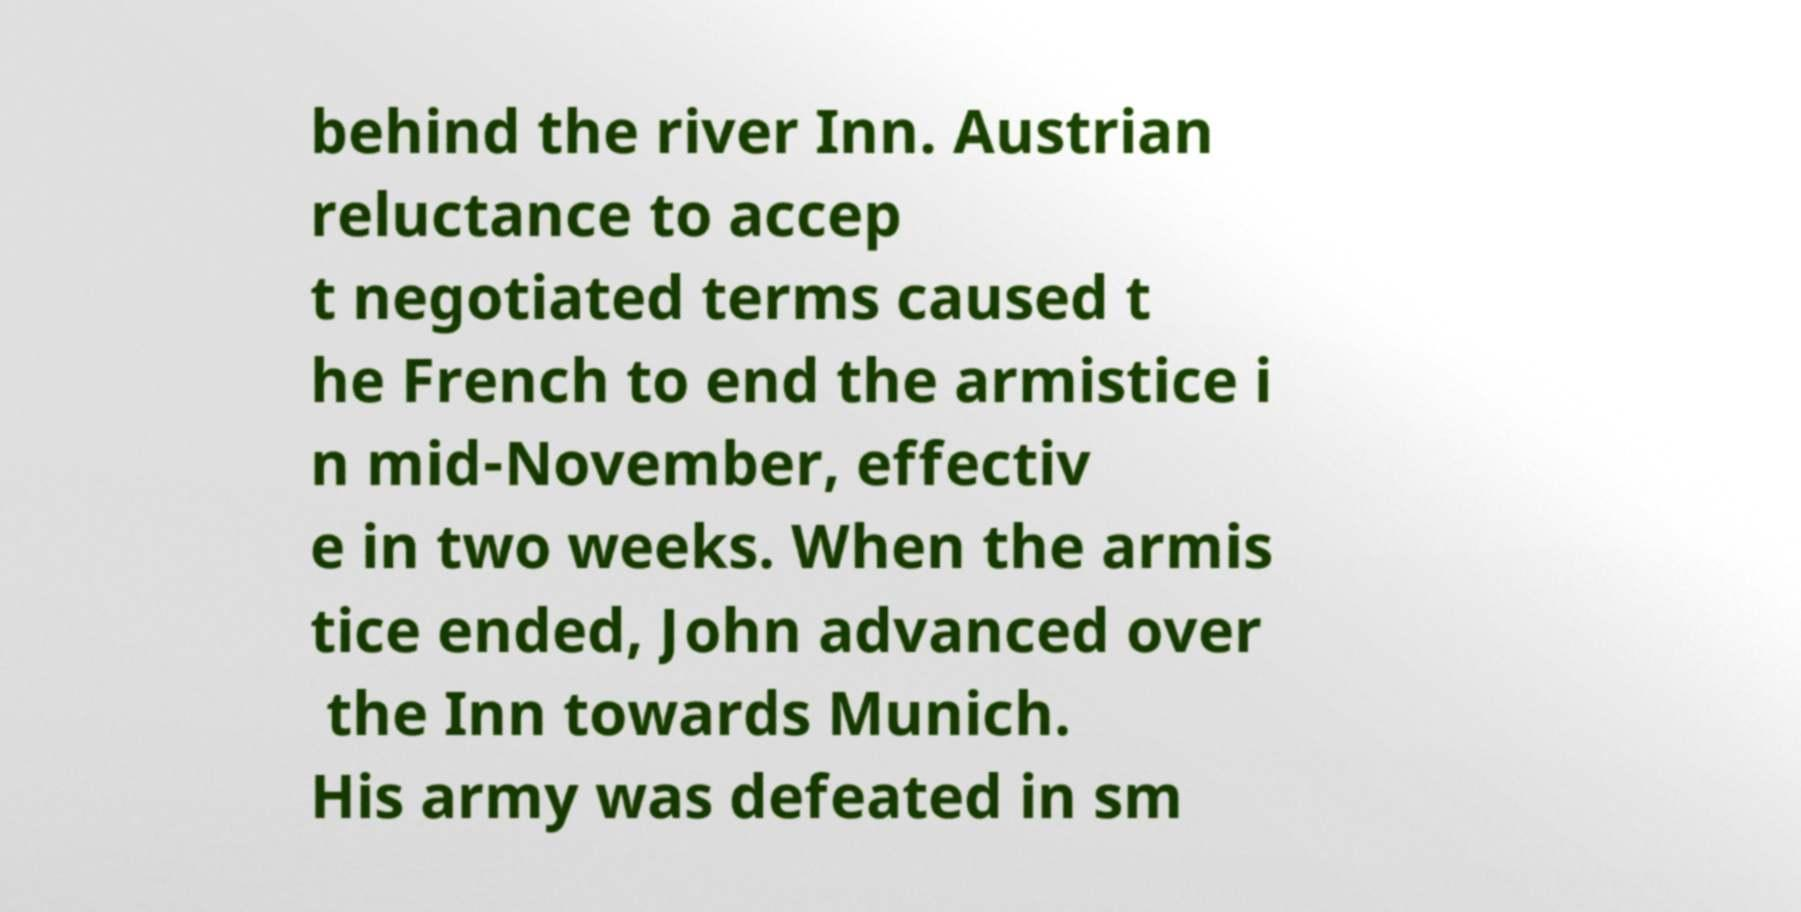For documentation purposes, I need the text within this image transcribed. Could you provide that? behind the river Inn. Austrian reluctance to accep t negotiated terms caused t he French to end the armistice i n mid-November, effectiv e in two weeks. When the armis tice ended, John advanced over the Inn towards Munich. His army was defeated in sm 